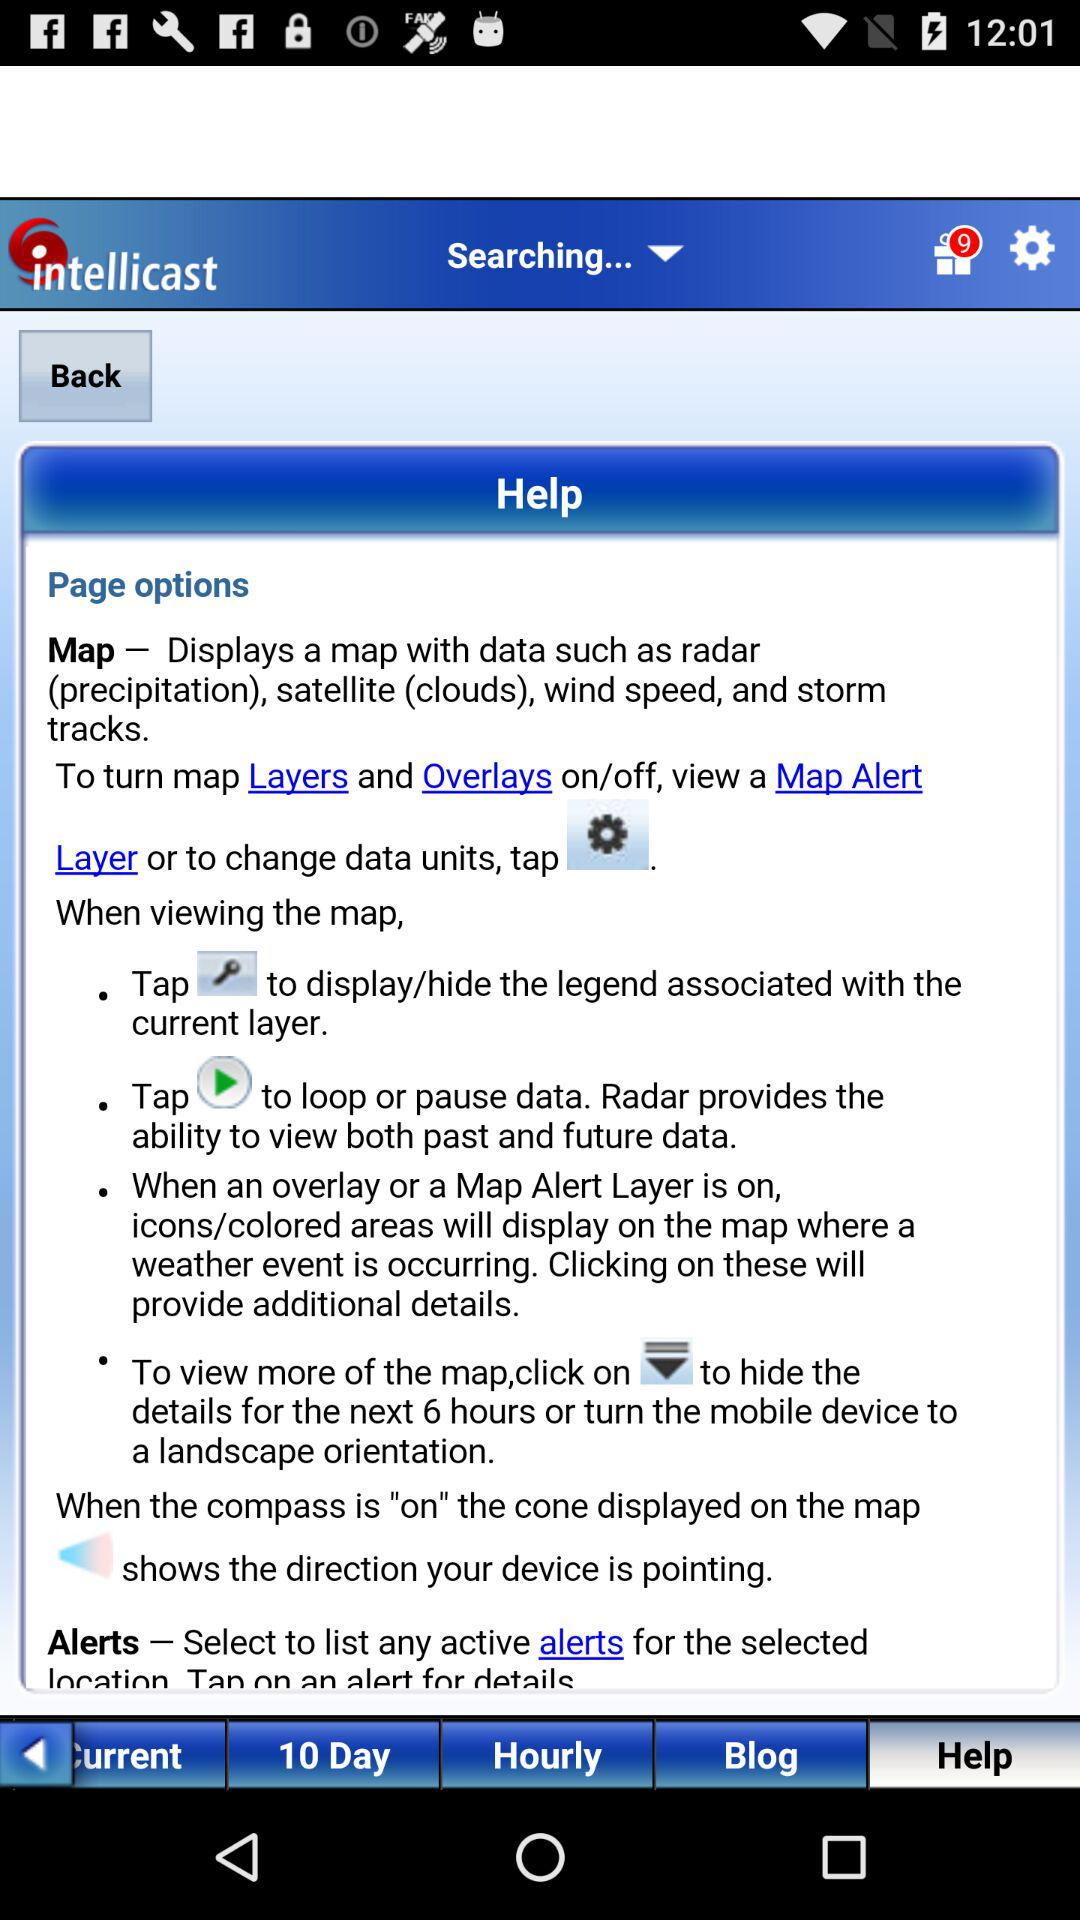How many more days are there in the 10 day forecast than in the hourly forecast?
Answer the question using a single word or phrase. 9 